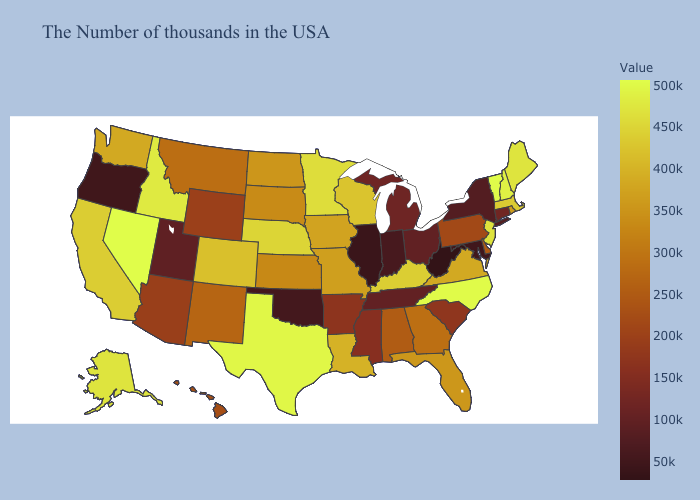Does Pennsylvania have the highest value in the Northeast?
Write a very short answer. No. Among the states that border Arizona , which have the highest value?
Short answer required. Nevada. Does Oregon have the lowest value in the West?
Give a very brief answer. Yes. Among the states that border Wisconsin , which have the lowest value?
Be succinct. Illinois. Does Oregon have the lowest value in the West?
Answer briefly. Yes. 